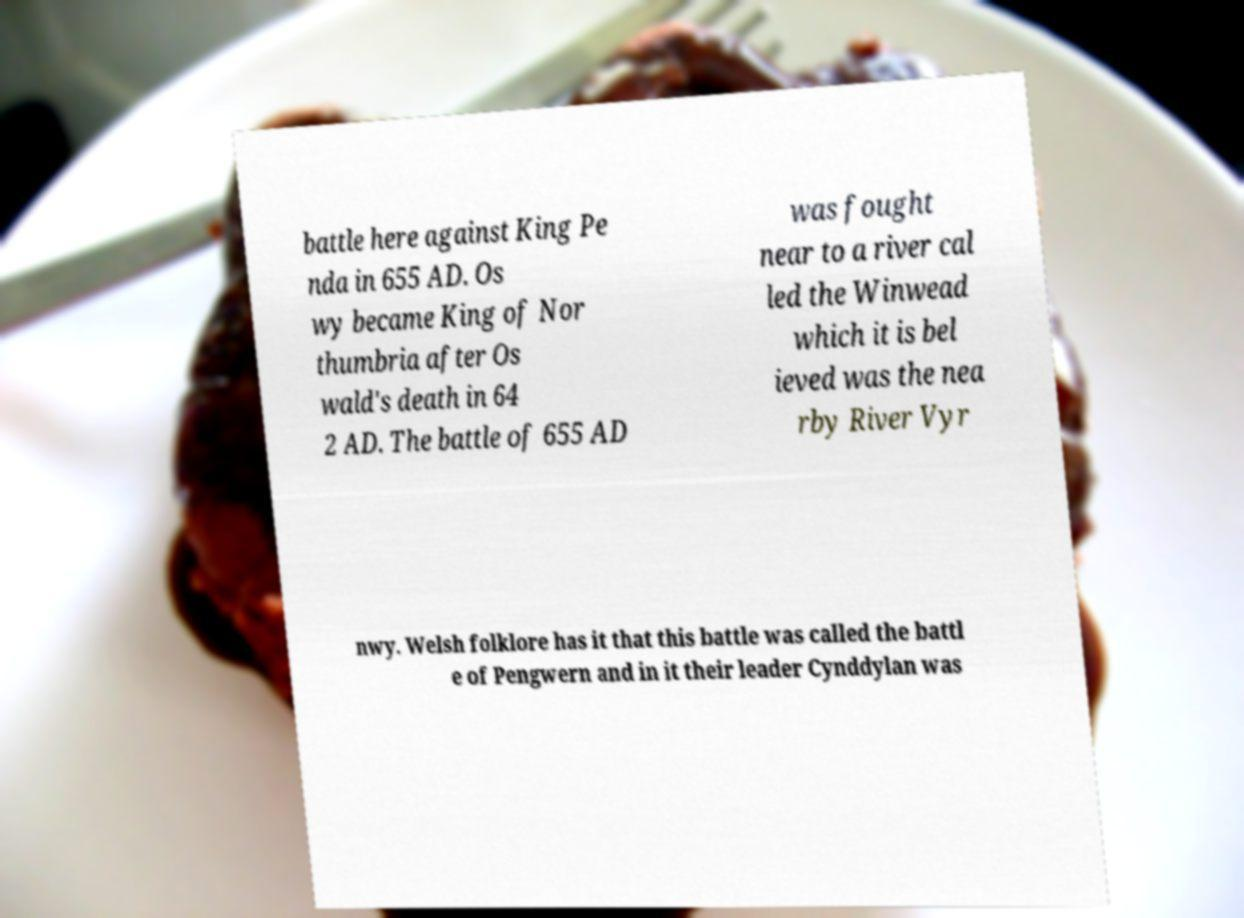I need the written content from this picture converted into text. Can you do that? battle here against King Pe nda in 655 AD. Os wy became King of Nor thumbria after Os wald's death in 64 2 AD. The battle of 655 AD was fought near to a river cal led the Winwead which it is bel ieved was the nea rby River Vyr nwy. Welsh folklore has it that this battle was called the battl e of Pengwern and in it their leader Cynddylan was 